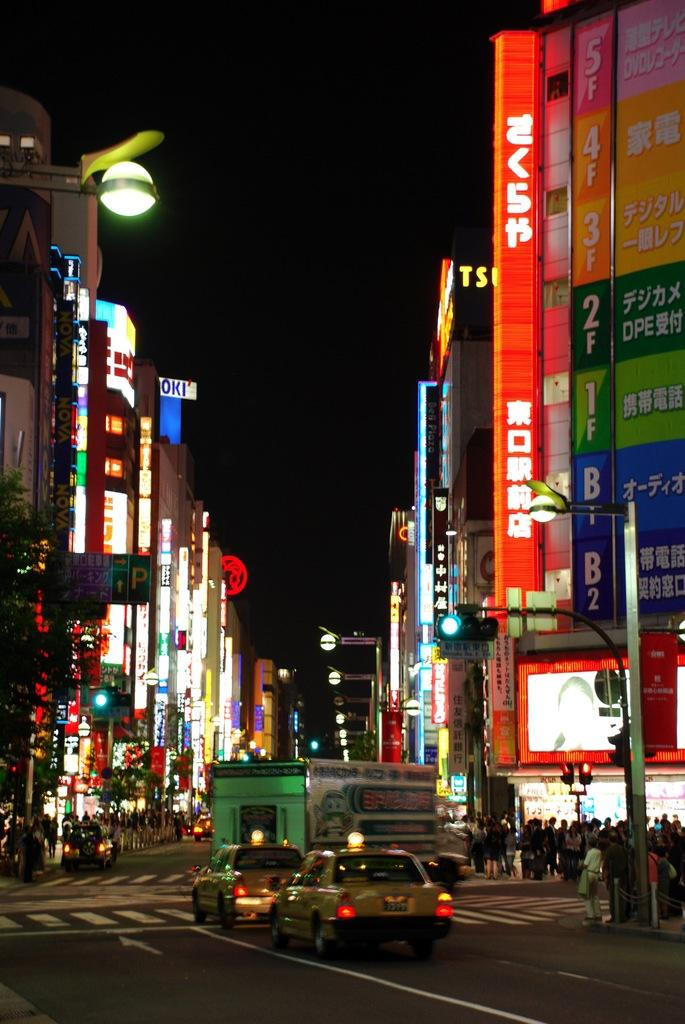Who or what can be seen in the image? There are people in the image. What else is visible on the road in the image? There are vehicles on the road in the image. What type of structures are present in the image? There are buildings in the image. Can you describe any illumination in the image? There are lights in the image. Are there any signs or messages visible in the image? There are boards with text in the image. How would you describe the overall appearance of the image? The background of the image is dark. What type of lace can be seen on the fish in the image? There is no fish or lace present in the image. What type of border is visible around the people in the image? There is: There is no border visible around the people in the image. 